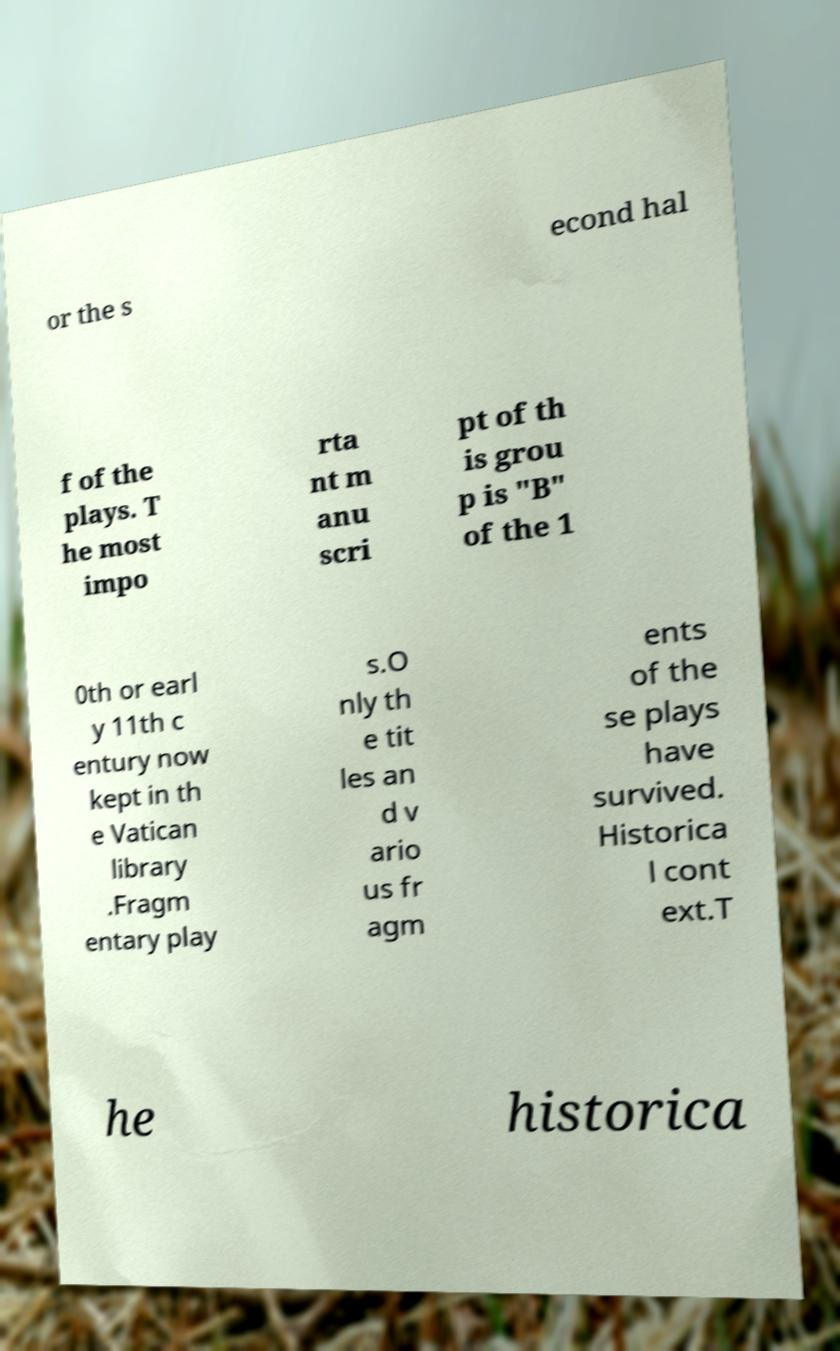Please identify and transcribe the text found in this image. or the s econd hal f of the plays. T he most impo rta nt m anu scri pt of th is grou p is "B" of the 1 0th or earl y 11th c entury now kept in th e Vatican library .Fragm entary play s.O nly th e tit les an d v ario us fr agm ents of the se plays have survived. Historica l cont ext.T he historica 